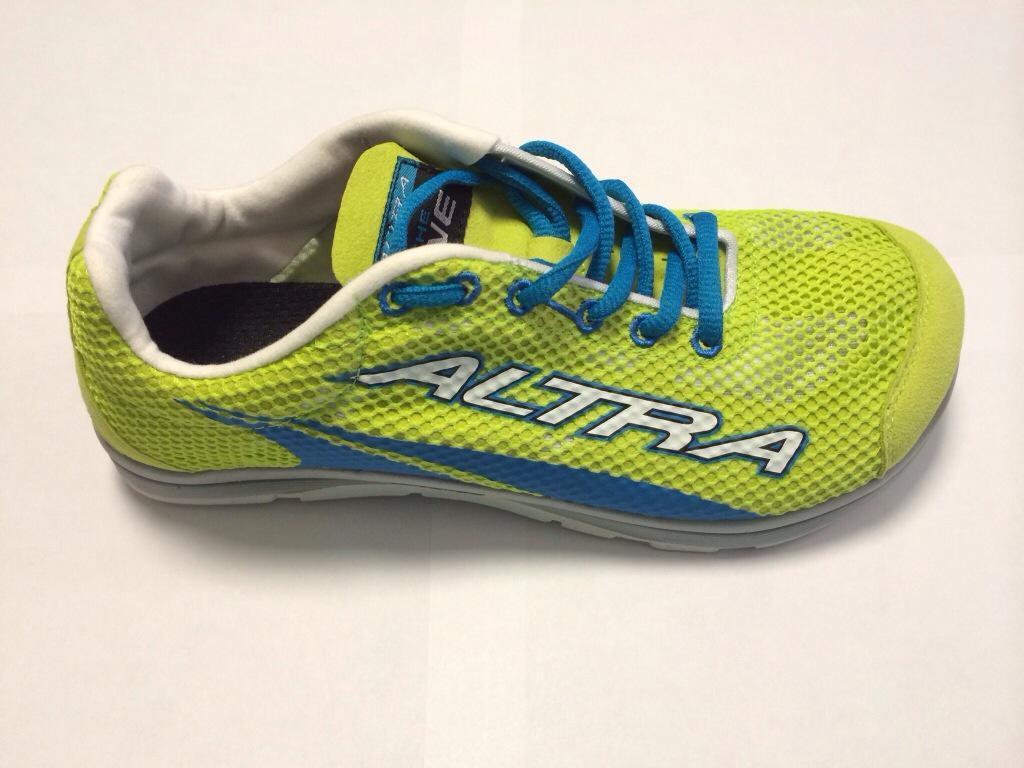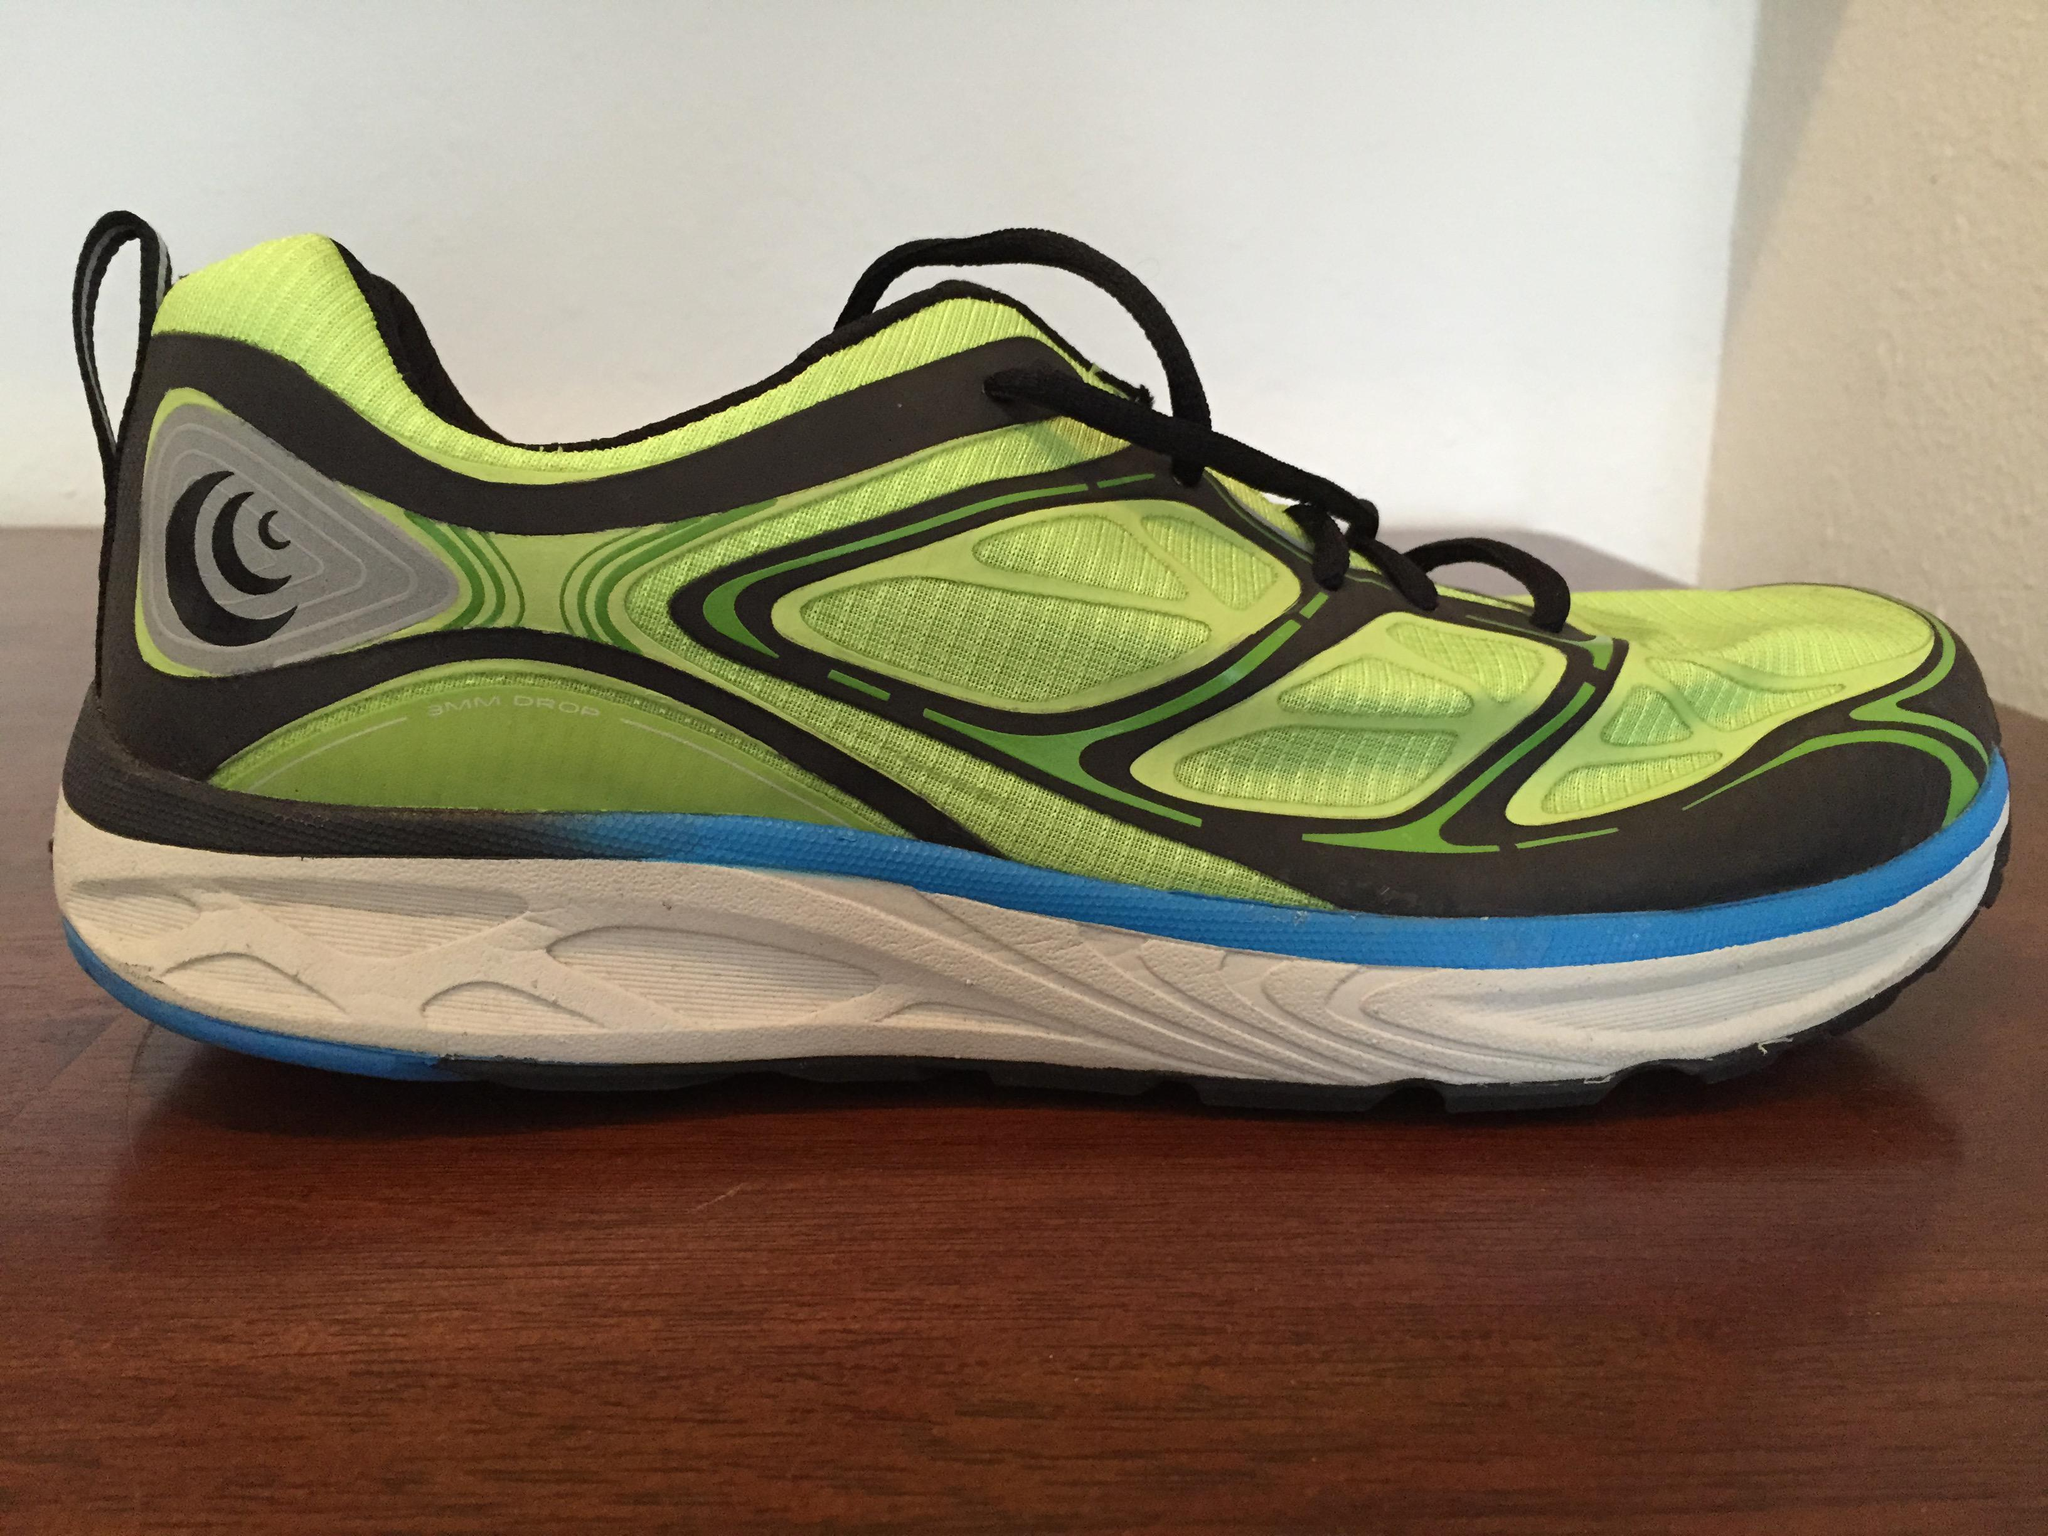The first image is the image on the left, the second image is the image on the right. Considering the images on both sides, is "A pair of shoes are on the right side." valid? Answer yes or no. No. 